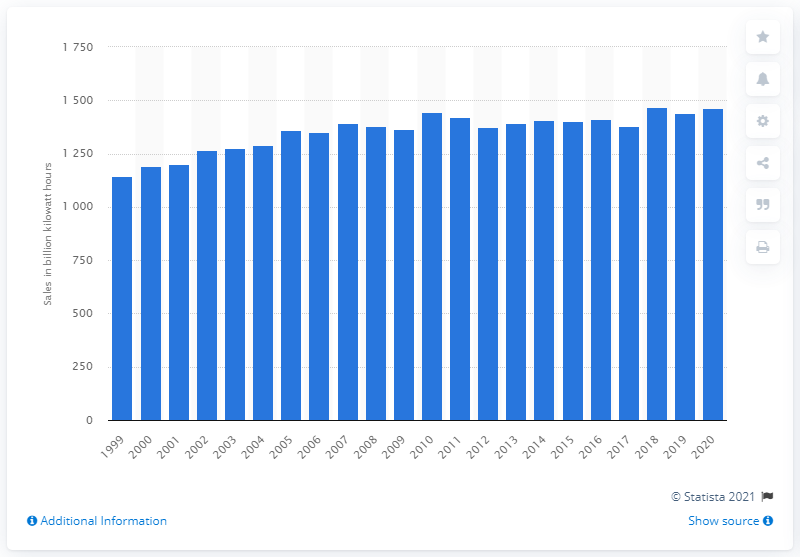List a handful of essential elements in this visual. In 2018, a peak in electricity retail sales was recorded. 